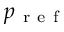<formula> <loc_0><loc_0><loc_500><loc_500>p _ { r e f }</formula> 